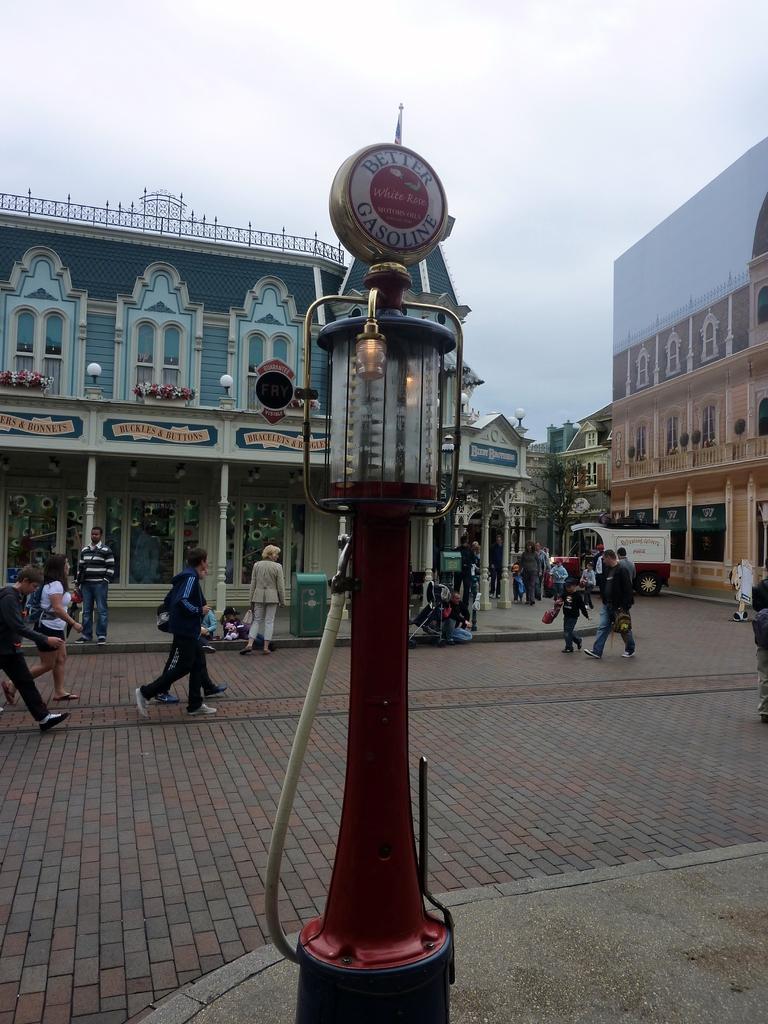In one or two sentences, can you explain what this image depicts? In this image we can see a filling station. In the background of the image there are some buildings, people, vehicle, lights, name boards and other objects. At the bottom of the image there is the floor. At the top of the image there is the sky. 